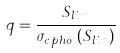<formula> <loc_0><loc_0><loc_500><loc_500>q = \frac { S _ { l i m } } { \sigma _ { c \, p h o t } ( S _ { l i m } ) }</formula> 